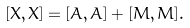<formula> <loc_0><loc_0><loc_500><loc_500>[ X , X ] = [ A , A ] + [ M , M ] .</formula> 